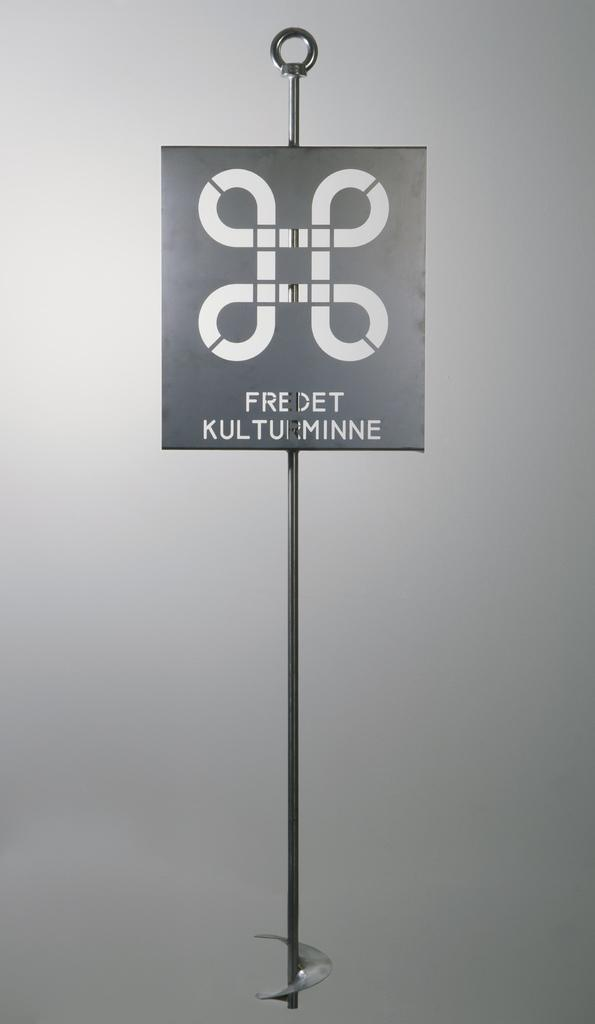What is the main object in the image? There is a board in the image. What other object can be seen in the image? There is a pole in the image. How many potatoes are on the board in the image? There is no potato present in the image. What type of self-improvement activity is being performed in the image? There is no self-improvement activity depicted in the image; it only shows a board and a pole. 